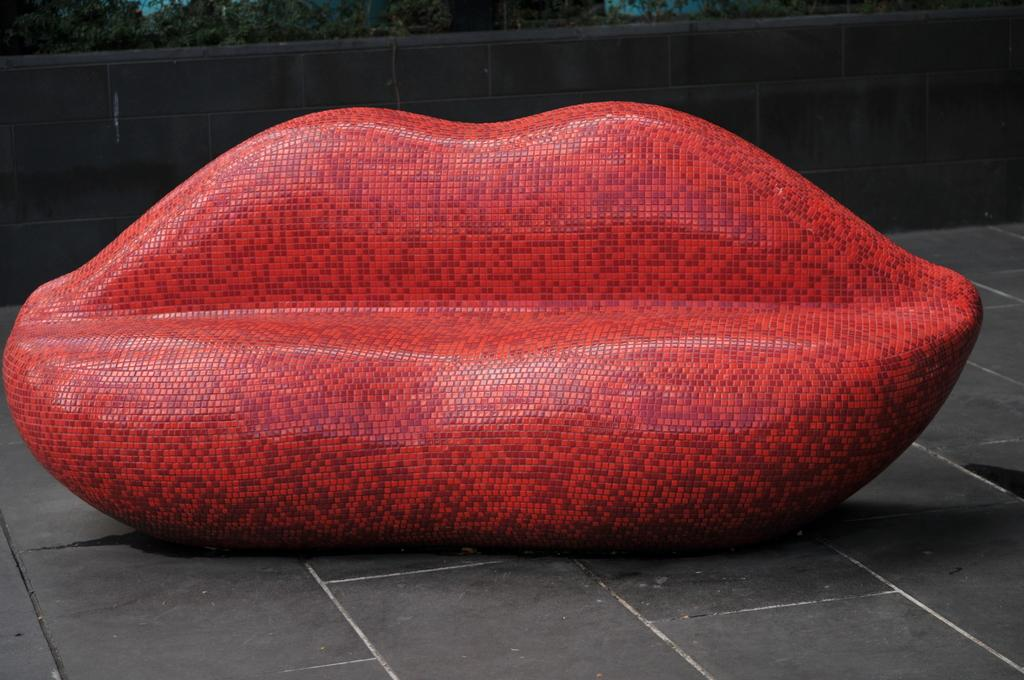What is the main object in the center of the image? There is a couch in the center of the image. What is unique about the design of the couch? The couch is in the form of a lip. What can be seen in the background of the image? There are trees and a wall in the background of the image. What is the surface on which the couch is placed? There is a floor at the bottom of the image. How many teeth can be seen on the goose in the image? There is no goose present in the image, and therefore no teeth can be observed. What type of donkey is sitting on the couch in the image? There is no donkey present in the image; the couch is in the form of a lip. 